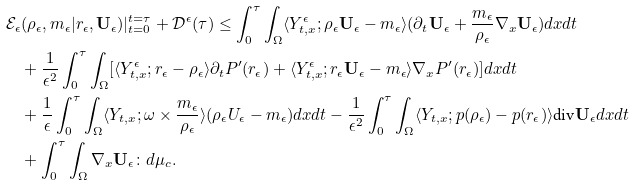<formula> <loc_0><loc_0><loc_500><loc_500>\mathcal { E } _ { \epsilon } & ( \rho _ { \epsilon } , m _ { \epsilon } | r _ { \epsilon } , \mathbf U _ { \epsilon } ) | ^ { t = \tau } _ { t = 0 } + \mathcal { D } ^ { \epsilon } ( \tau ) \leq \int ^ { \tau } _ { 0 } \int _ { \Omega } \langle Y ^ { \epsilon } _ { t , x } ; \rho _ { \epsilon } \mathbf U _ { \epsilon } - m _ { \epsilon } \rangle ( \partial _ { t } \mathbf U _ { \epsilon } + \frac { m _ { \epsilon } } { \rho _ { \epsilon } } \nabla _ { x } \mathbf U _ { \epsilon } ) d x d t \\ & + \frac { 1 } { \epsilon ^ { 2 } } \int ^ { \tau } _ { 0 } \int _ { \Omega } [ \langle Y ^ { \epsilon } _ { t , x } ; r _ { \epsilon } - \rho _ { \epsilon } \rangle \partial _ { t } P ^ { \prime } ( r _ { \epsilon } ) + \langle Y ^ { \epsilon } _ { t , x } ; r _ { \epsilon } \mathbf U _ { \epsilon } - m _ { \epsilon } \rangle \nabla _ { x } P ^ { \prime } ( r _ { \epsilon } ) ] d x d t \\ & + \frac { 1 } { \epsilon } \int ^ { \tau } _ { 0 } \int _ { \Omega } \langle Y _ { t , x } ; \omega \times \frac { m _ { \epsilon } } { \rho _ { \epsilon } } \rangle ( \rho _ { \epsilon } U _ { \epsilon } - m _ { \epsilon } ) d x d t - \frac { 1 } { \epsilon ^ { 2 } } \int ^ { \tau } _ { 0 } \int _ { \Omega } \langle Y _ { t , x } ; p ( \rho _ { \epsilon } ) - p ( r _ { \epsilon } ) \rangle \text {div} \mathbf U _ { \epsilon } d x d t \\ & + \int ^ { \tau } _ { 0 } \int _ { \Omega } \nabla _ { x } \mathbf U _ { \epsilon } \colon d \mu _ { c } .</formula> 